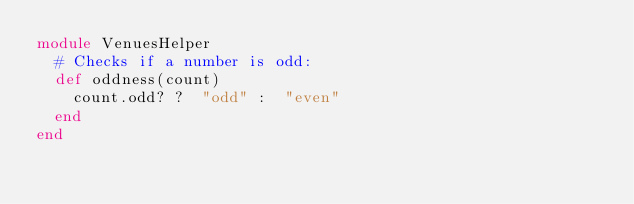Convert code to text. <code><loc_0><loc_0><loc_500><loc_500><_Ruby_>module VenuesHelper
  # Checks if a number is odd:
  def oddness(count)
    count.odd? ?  "odd" :  "even"
  end
end
</code> 